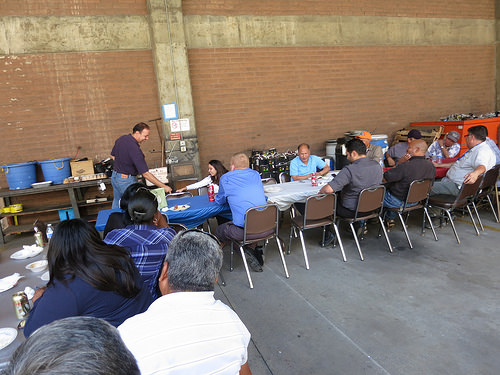<image>
Is the head on the shirt? No. The head is not positioned on the shirt. They may be near each other, but the head is not supported by or resting on top of the shirt. Is the man behind the woman? Yes. From this viewpoint, the man is positioned behind the woman, with the woman partially or fully occluding the man. Is the man in front of the woman? No. The man is not in front of the woman. The spatial positioning shows a different relationship between these objects. 